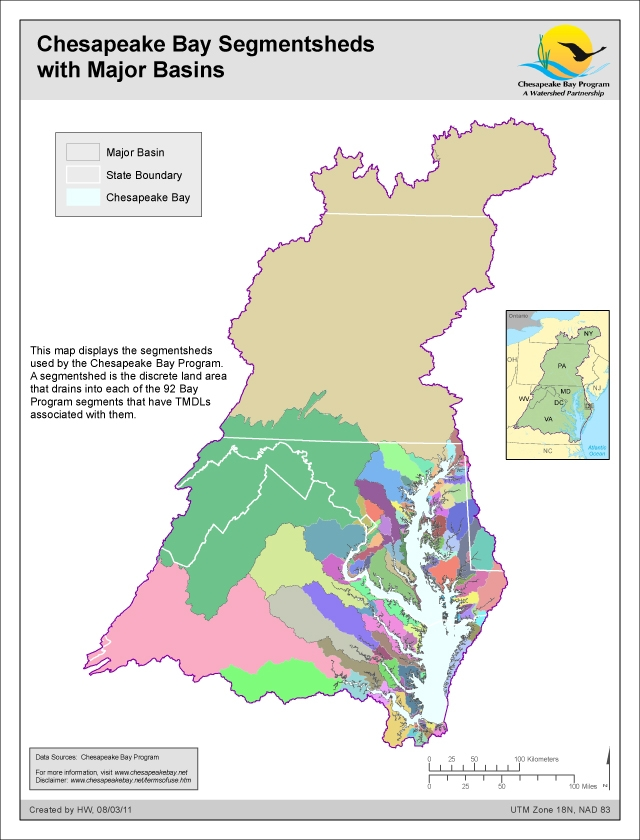Discuss a potential real-life scenario where an environmental policy change in one state could affect the entire Chesapeake Bay watershed. Consider a scenario where a state government situated in the northern part of the Chesapeake Bay watershed decides to implement stringent agricultural runoff regulations. This policy aims to reduce the levels of nitrogen and phosphorus entering the waterways, which are significant contributors to the Bay's nutrient pollution. By enforcing these regulations, the state could significantly lessen the nutrient loads in its segmentsheds. This reduction would enhance water quality, promote healthier aquatic ecosystems, and decrease the frequency and intensity of algal blooms in the Bay. However, for this positive change to have a lasting and Bay-wide impact, it must be complemented by similar policies in neighboring states within the watershed. Interstate collaboration would ensure consistent reductions in runoff contaminants, leading to a more comprehensive improvement in the Bay's overall health. Such a coordinated effort highlights the interconnectedness of environmental policies and the importance of unified actions across state boundaries. 